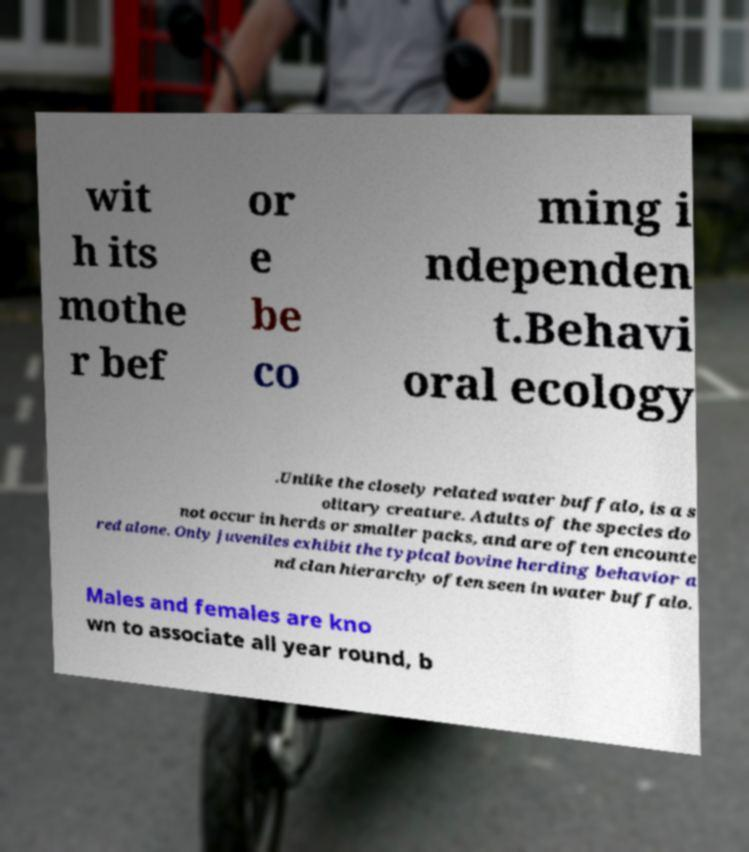What messages or text are displayed in this image? I need them in a readable, typed format. wit h its mothe r bef or e be co ming i ndependen t.Behavi oral ecology .Unlike the closely related water buffalo, is a s olitary creature. Adults of the species do not occur in herds or smaller packs, and are often encounte red alone. Only juveniles exhibit the typical bovine herding behavior a nd clan hierarchy often seen in water buffalo. Males and females are kno wn to associate all year round, b 